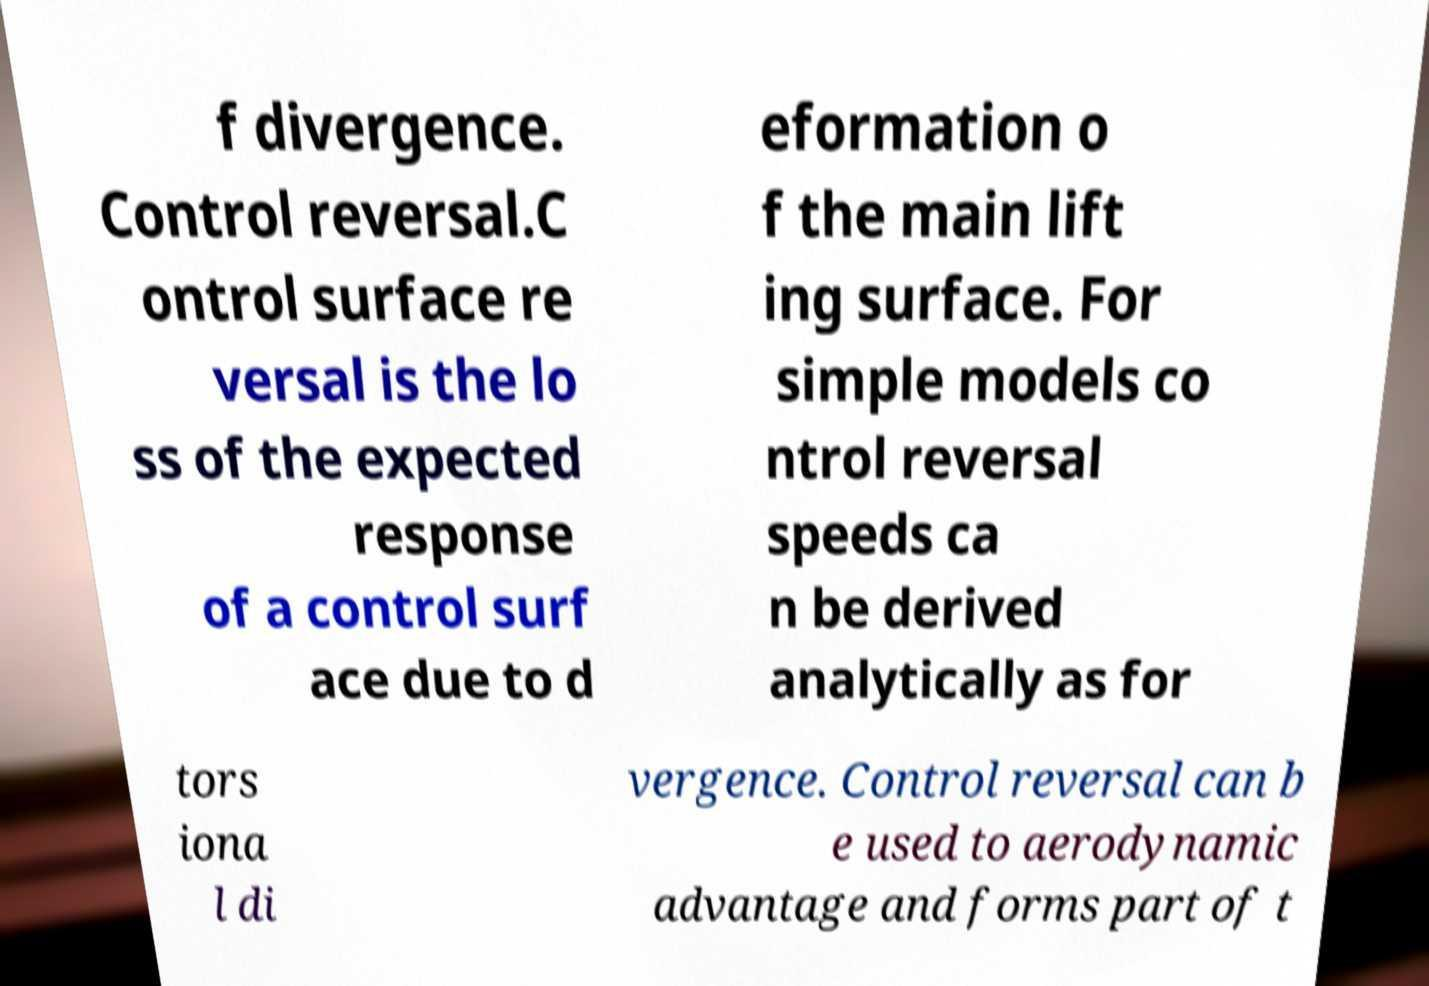There's text embedded in this image that I need extracted. Can you transcribe it verbatim? f divergence. Control reversal.C ontrol surface re versal is the lo ss of the expected response of a control surf ace due to d eformation o f the main lift ing surface. For simple models co ntrol reversal speeds ca n be derived analytically as for tors iona l di vergence. Control reversal can b e used to aerodynamic advantage and forms part of t 